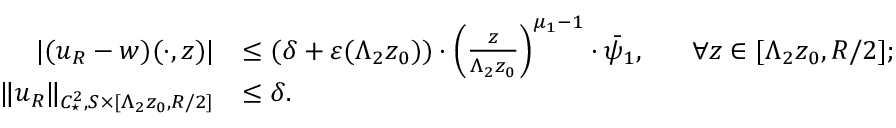<formula> <loc_0><loc_0><loc_500><loc_500>\begin{array} { r l } { | ( u _ { R } - w ) ( \cdot , z ) | } & { \leq ( \delta + \varepsilon ( \Lambda _ { 2 } z _ { 0 } ) ) \cdot \left ( \frac { z } { \Lambda _ { 2 } z _ { 0 } } \right ) ^ { \mu _ { 1 } - 1 } \cdot \bar { \psi } _ { 1 } , \quad \ \forall z \in [ \Lambda _ { 2 } z _ { 0 } , R / 2 ] ; } \\ { \| u _ { R } \| _ { C _ { ^ { * } } ^ { 2 } , S \times [ \Lambda _ { 2 } z _ { 0 } , R / 2 ] } } & { \leq \delta . } \end{array}</formula> 